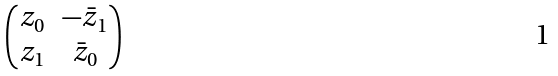<formula> <loc_0><loc_0><loc_500><loc_500>\begin{pmatrix} z _ { 0 } & - \bar { z } _ { 1 } \\ z _ { 1 } & \bar { z } _ { 0 } \end{pmatrix}</formula> 